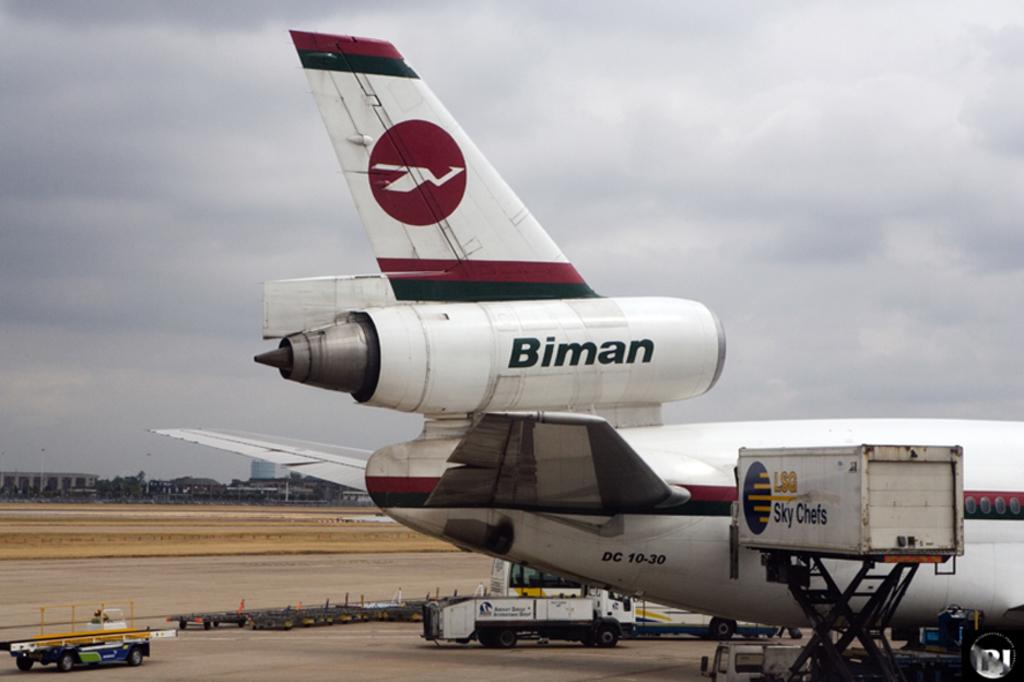<image>
Create a compact narrative representing the image presented. A Biman passenger jet is shown parked at an airport. 